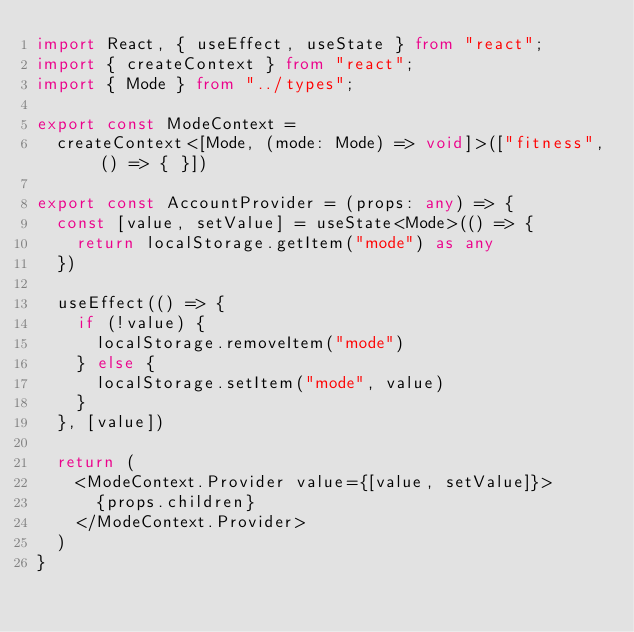<code> <loc_0><loc_0><loc_500><loc_500><_TypeScript_>import React, { useEffect, useState } from "react";
import { createContext } from "react";
import { Mode } from "../types";

export const ModeContext =
  createContext<[Mode, (mode: Mode) => void]>(["fitness", () => { }])

export const AccountProvider = (props: any) => {
  const [value, setValue] = useState<Mode>(() => {
    return localStorage.getItem("mode") as any
  })

  useEffect(() => {
    if (!value) {
      localStorage.removeItem("mode")
    } else {
      localStorage.setItem("mode", value)
    }
  }, [value])

  return (
    <ModeContext.Provider value={[value, setValue]}>
      {props.children}
    </ModeContext.Provider>
  )
}
</code> 